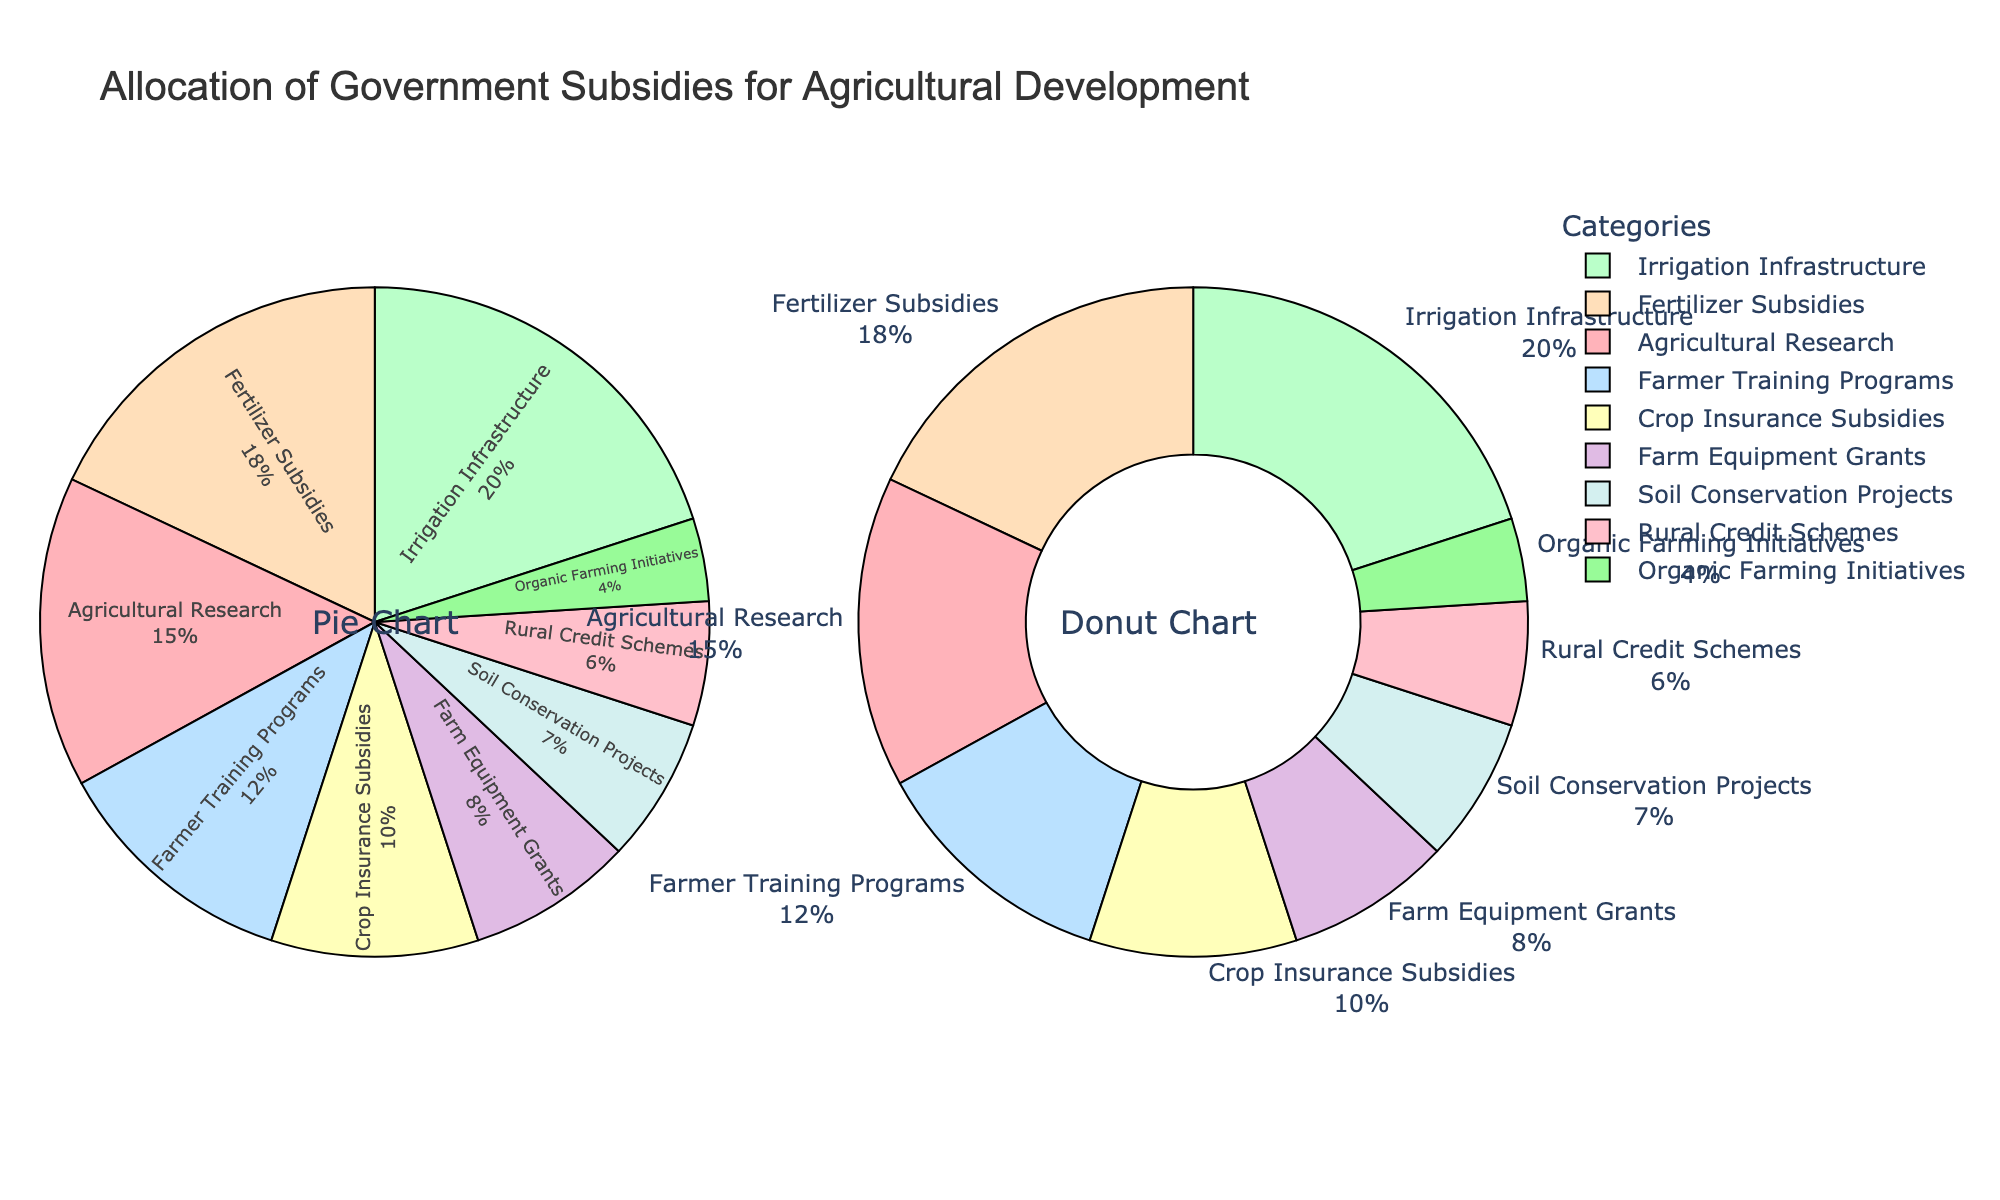How much of the subsidies are allocated to Agricultural Research and Irrigation Infrastructure combined? Sum the percentages for Agricultural Research (15%) and Irrigation Infrastructure (20%), giving a total of 15 + 20 = 35
Answer: 35% Which category receives a higher percentage of subsidies: Fertilizer Subsidies or Farmer Training Programs? Fertilizer Subsidies receive 18%, whereas Farmer Training Programs receive 12%. 18% is higher than 12%
Answer: Fertilizer Subsidies What percentage of subsidies is allocated to Soil Conservation Projects compared to Crop Insurance Subsidies? Soil Conservation Projects receive 7% and Crop Insurance Subsidies receive 10%. 7% is less than 10%
Answer: Soil Conservation Projects How many categories receive less than 10% of the subsidies each? The categories receiving less than 10% are Farm Equipment Grants (8%), Soil Conservation Projects (7%), Rural Credit Schemes (6%), and Organic Farming Initiatives (4%). Summing these counts, we get 4 categories
Answer: 4 What is the percentage difference between the highest and lowest funded categories? The highest funded category is Irrigation Infrastructure (20%), and the lowest funded category is Organic Farming Initiatives (4%). The difference is 20 - 4 = 16
Answer: 16% What is the average percentage of subsidies allocated to Crop Insurance Subsidies, Fertilizer Subsidies, and Farm Equipment Grants? Add the percentages of Crop Insurance Subsidies (10%), Fertilizer Subsidies (18%), and Farm Equipment Grants (8%), then divide by 3. The sum is 10 + 18 + 8 = 36, and the average is 36 / 3 = 12
Answer: 12% Which two categories combined receive the same percentage of subsidies as Farmer Training Programs? Farmer Training Programs receive 12%. Rural Credit Schemes (6%) and Organic Farming Initiatives (4%) combined have 6 + 4 = 10, not equal to 12. Soil Conservation Projects (7%) and Rural Credit Schemes (6%) combined have 7 + 6 = 13, also not equal to 12. Farm Equipment Grants (8%) and Rural Credit Schemes (6%) combined have 8 + 6 = 14. None of the pairs exactly match, but these are close
Answer: None What visual cue indicates the category with the smallest subsidy allocation? The smallest slice in both the Pie Chart and Donut Chart represents the smallest allocation. Organic Farming Initiatives have the smallest slice
Answer: Organic Farming Initiatives Is the sum of the subsidies for Farmer Training Programs and Fertilizer Subsidies greater than the subsidy for Irrigation Infrastructure? Farmer Training Programs have 12% and Fertilizer Subsidies have 18%. Their sum is 12 + 18 = 30%. Irrigation Infrastructure has 20%. 30% is greater than 20%
Answer: Yes 